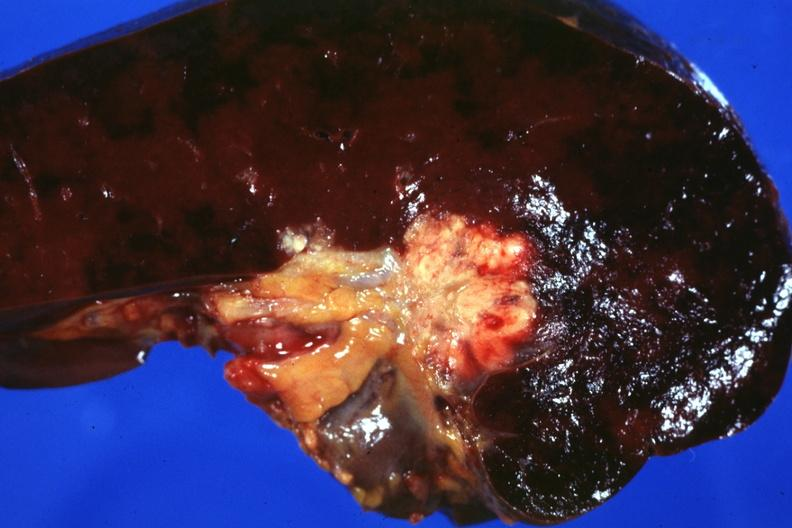what spread into the spleen in this case?
Answer the question using a single word or phrase. Node metastases 